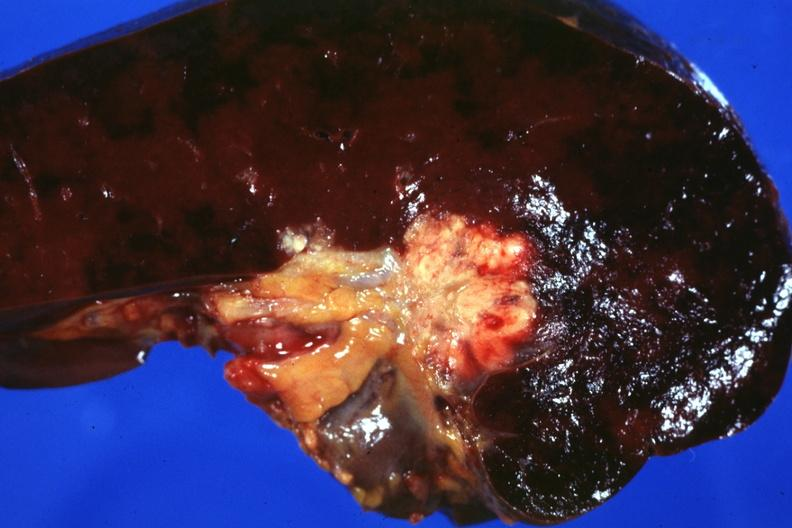what spread into the spleen in this case?
Answer the question using a single word or phrase. Node metastases 